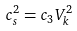Convert formula to latex. <formula><loc_0><loc_0><loc_500><loc_500>c _ { s } ^ { 2 } = c _ { 3 } V _ { k } ^ { 2 }</formula> 